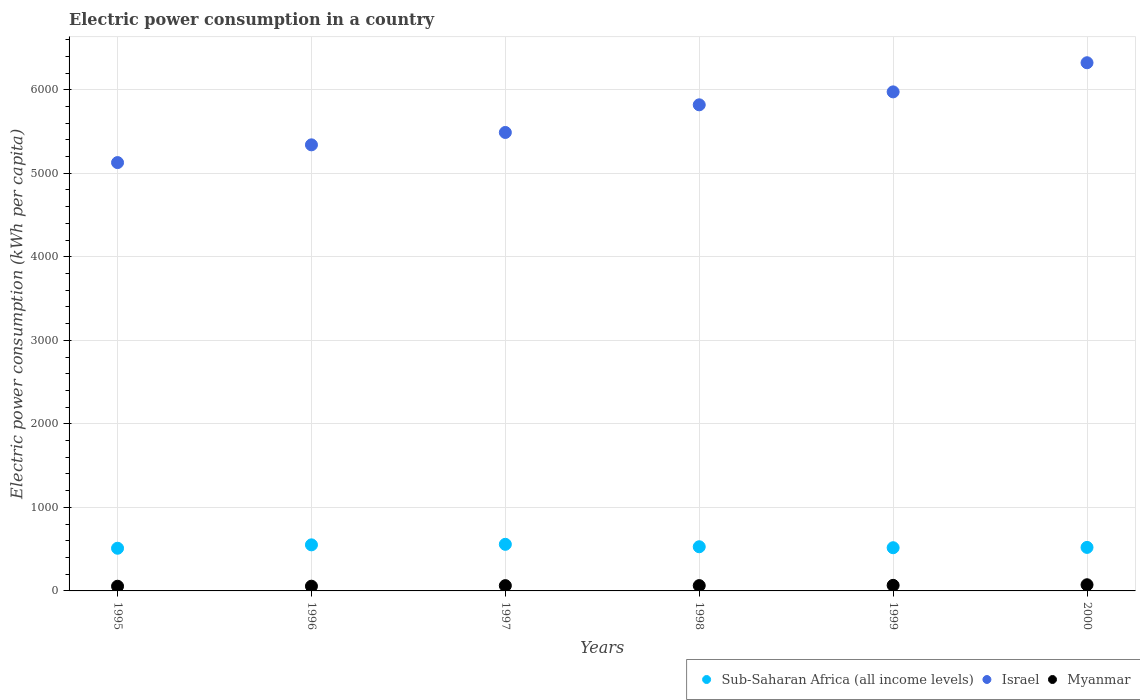Is the number of dotlines equal to the number of legend labels?
Make the answer very short. Yes. What is the electric power consumption in in Sub-Saharan Africa (all income levels) in 2000?
Your response must be concise. 520.97. Across all years, what is the maximum electric power consumption in in Myanmar?
Offer a very short reply. 73.76. Across all years, what is the minimum electric power consumption in in Israel?
Provide a succinct answer. 5127.86. In which year was the electric power consumption in in Myanmar maximum?
Keep it short and to the point. 2000. In which year was the electric power consumption in in Myanmar minimum?
Offer a terse response. 1995. What is the total electric power consumption in in Myanmar in the graph?
Provide a short and direct response. 380.1. What is the difference between the electric power consumption in in Myanmar in 1995 and that in 1996?
Your answer should be compact. -0.43. What is the difference between the electric power consumption in in Israel in 1995 and the electric power consumption in in Myanmar in 2000?
Provide a succinct answer. 5054.11. What is the average electric power consumption in in Israel per year?
Provide a succinct answer. 5678.94. In the year 1999, what is the difference between the electric power consumption in in Myanmar and electric power consumption in in Sub-Saharan Africa (all income levels)?
Your answer should be compact. -450.33. In how many years, is the electric power consumption in in Myanmar greater than 3400 kWh per capita?
Provide a succinct answer. 0. What is the ratio of the electric power consumption in in Israel in 1995 to that in 1997?
Ensure brevity in your answer.  0.93. Is the electric power consumption in in Myanmar in 1997 less than that in 1999?
Provide a succinct answer. Yes. What is the difference between the highest and the second highest electric power consumption in in Myanmar?
Offer a very short reply. 6.99. What is the difference between the highest and the lowest electric power consumption in in Israel?
Give a very brief answer. 1195.24. In how many years, is the electric power consumption in in Israel greater than the average electric power consumption in in Israel taken over all years?
Ensure brevity in your answer.  3. Is the sum of the electric power consumption in in Myanmar in 1996 and 1998 greater than the maximum electric power consumption in in Israel across all years?
Provide a succinct answer. No. Does the electric power consumption in in Sub-Saharan Africa (all income levels) monotonically increase over the years?
Your answer should be compact. No. Is the electric power consumption in in Myanmar strictly less than the electric power consumption in in Sub-Saharan Africa (all income levels) over the years?
Offer a terse response. Yes. How many years are there in the graph?
Your answer should be compact. 6. Are the values on the major ticks of Y-axis written in scientific E-notation?
Make the answer very short. No. Does the graph contain any zero values?
Give a very brief answer. No. Does the graph contain grids?
Ensure brevity in your answer.  Yes. Where does the legend appear in the graph?
Make the answer very short. Bottom right. How are the legend labels stacked?
Make the answer very short. Horizontal. What is the title of the graph?
Your answer should be very brief. Electric power consumption in a country. Does "Belgium" appear as one of the legend labels in the graph?
Give a very brief answer. No. What is the label or title of the Y-axis?
Provide a short and direct response. Electric power consumption (kWh per capita). What is the Electric power consumption (kWh per capita) of Sub-Saharan Africa (all income levels) in 1995?
Make the answer very short. 510.9. What is the Electric power consumption (kWh per capita) in Israel in 1995?
Make the answer very short. 5127.86. What is the Electric power consumption (kWh per capita) of Myanmar in 1995?
Keep it short and to the point. 56.14. What is the Electric power consumption (kWh per capita) of Sub-Saharan Africa (all income levels) in 1996?
Your answer should be compact. 551.54. What is the Electric power consumption (kWh per capita) of Israel in 1996?
Provide a succinct answer. 5340.3. What is the Electric power consumption (kWh per capita) of Myanmar in 1996?
Offer a terse response. 56.57. What is the Electric power consumption (kWh per capita) of Sub-Saharan Africa (all income levels) in 1997?
Ensure brevity in your answer.  557.91. What is the Electric power consumption (kWh per capita) of Israel in 1997?
Your answer should be compact. 5488.52. What is the Electric power consumption (kWh per capita) in Myanmar in 1997?
Make the answer very short. 63.25. What is the Electric power consumption (kWh per capita) in Sub-Saharan Africa (all income levels) in 1998?
Ensure brevity in your answer.  528.77. What is the Electric power consumption (kWh per capita) in Israel in 1998?
Your response must be concise. 5819.46. What is the Electric power consumption (kWh per capita) of Myanmar in 1998?
Ensure brevity in your answer.  63.62. What is the Electric power consumption (kWh per capita) in Sub-Saharan Africa (all income levels) in 1999?
Your response must be concise. 517.1. What is the Electric power consumption (kWh per capita) of Israel in 1999?
Keep it short and to the point. 5974.37. What is the Electric power consumption (kWh per capita) of Myanmar in 1999?
Keep it short and to the point. 66.76. What is the Electric power consumption (kWh per capita) of Sub-Saharan Africa (all income levels) in 2000?
Your answer should be very brief. 520.97. What is the Electric power consumption (kWh per capita) in Israel in 2000?
Keep it short and to the point. 6323.1. What is the Electric power consumption (kWh per capita) in Myanmar in 2000?
Your answer should be compact. 73.76. Across all years, what is the maximum Electric power consumption (kWh per capita) in Sub-Saharan Africa (all income levels)?
Give a very brief answer. 557.91. Across all years, what is the maximum Electric power consumption (kWh per capita) in Israel?
Give a very brief answer. 6323.1. Across all years, what is the maximum Electric power consumption (kWh per capita) in Myanmar?
Ensure brevity in your answer.  73.76. Across all years, what is the minimum Electric power consumption (kWh per capita) of Sub-Saharan Africa (all income levels)?
Your answer should be compact. 510.9. Across all years, what is the minimum Electric power consumption (kWh per capita) in Israel?
Offer a terse response. 5127.86. Across all years, what is the minimum Electric power consumption (kWh per capita) in Myanmar?
Offer a terse response. 56.14. What is the total Electric power consumption (kWh per capita) of Sub-Saharan Africa (all income levels) in the graph?
Ensure brevity in your answer.  3187.19. What is the total Electric power consumption (kWh per capita) of Israel in the graph?
Offer a terse response. 3.41e+04. What is the total Electric power consumption (kWh per capita) of Myanmar in the graph?
Offer a very short reply. 380.1. What is the difference between the Electric power consumption (kWh per capita) of Sub-Saharan Africa (all income levels) in 1995 and that in 1996?
Give a very brief answer. -40.64. What is the difference between the Electric power consumption (kWh per capita) in Israel in 1995 and that in 1996?
Your answer should be compact. -212.44. What is the difference between the Electric power consumption (kWh per capita) in Myanmar in 1995 and that in 1996?
Offer a very short reply. -0.43. What is the difference between the Electric power consumption (kWh per capita) of Sub-Saharan Africa (all income levels) in 1995 and that in 1997?
Give a very brief answer. -47.01. What is the difference between the Electric power consumption (kWh per capita) in Israel in 1995 and that in 1997?
Offer a terse response. -360.66. What is the difference between the Electric power consumption (kWh per capita) in Myanmar in 1995 and that in 1997?
Offer a terse response. -7.11. What is the difference between the Electric power consumption (kWh per capita) in Sub-Saharan Africa (all income levels) in 1995 and that in 1998?
Make the answer very short. -17.87. What is the difference between the Electric power consumption (kWh per capita) of Israel in 1995 and that in 1998?
Keep it short and to the point. -691.6. What is the difference between the Electric power consumption (kWh per capita) of Myanmar in 1995 and that in 1998?
Offer a very short reply. -7.48. What is the difference between the Electric power consumption (kWh per capita) in Sub-Saharan Africa (all income levels) in 1995 and that in 1999?
Provide a short and direct response. -6.19. What is the difference between the Electric power consumption (kWh per capita) of Israel in 1995 and that in 1999?
Your response must be concise. -846.5. What is the difference between the Electric power consumption (kWh per capita) of Myanmar in 1995 and that in 1999?
Your answer should be very brief. -10.62. What is the difference between the Electric power consumption (kWh per capita) of Sub-Saharan Africa (all income levels) in 1995 and that in 2000?
Make the answer very short. -10.07. What is the difference between the Electric power consumption (kWh per capita) in Israel in 1995 and that in 2000?
Provide a succinct answer. -1195.24. What is the difference between the Electric power consumption (kWh per capita) in Myanmar in 1995 and that in 2000?
Make the answer very short. -17.62. What is the difference between the Electric power consumption (kWh per capita) in Sub-Saharan Africa (all income levels) in 1996 and that in 1997?
Your answer should be very brief. -6.37. What is the difference between the Electric power consumption (kWh per capita) of Israel in 1996 and that in 1997?
Give a very brief answer. -148.22. What is the difference between the Electric power consumption (kWh per capita) in Myanmar in 1996 and that in 1997?
Make the answer very short. -6.68. What is the difference between the Electric power consumption (kWh per capita) in Sub-Saharan Africa (all income levels) in 1996 and that in 1998?
Offer a very short reply. 22.77. What is the difference between the Electric power consumption (kWh per capita) in Israel in 1996 and that in 1998?
Keep it short and to the point. -479.16. What is the difference between the Electric power consumption (kWh per capita) in Myanmar in 1996 and that in 1998?
Offer a very short reply. -7.05. What is the difference between the Electric power consumption (kWh per capita) in Sub-Saharan Africa (all income levels) in 1996 and that in 1999?
Offer a terse response. 34.45. What is the difference between the Electric power consumption (kWh per capita) in Israel in 1996 and that in 1999?
Give a very brief answer. -634.07. What is the difference between the Electric power consumption (kWh per capita) in Myanmar in 1996 and that in 1999?
Your answer should be compact. -10.2. What is the difference between the Electric power consumption (kWh per capita) in Sub-Saharan Africa (all income levels) in 1996 and that in 2000?
Offer a very short reply. 30.57. What is the difference between the Electric power consumption (kWh per capita) in Israel in 1996 and that in 2000?
Make the answer very short. -982.8. What is the difference between the Electric power consumption (kWh per capita) of Myanmar in 1996 and that in 2000?
Your response must be concise. -17.19. What is the difference between the Electric power consumption (kWh per capita) in Sub-Saharan Africa (all income levels) in 1997 and that in 1998?
Make the answer very short. 29.15. What is the difference between the Electric power consumption (kWh per capita) in Israel in 1997 and that in 1998?
Your answer should be very brief. -330.94. What is the difference between the Electric power consumption (kWh per capita) in Myanmar in 1997 and that in 1998?
Make the answer very short. -0.37. What is the difference between the Electric power consumption (kWh per capita) of Sub-Saharan Africa (all income levels) in 1997 and that in 1999?
Keep it short and to the point. 40.82. What is the difference between the Electric power consumption (kWh per capita) of Israel in 1997 and that in 1999?
Keep it short and to the point. -485.85. What is the difference between the Electric power consumption (kWh per capita) of Myanmar in 1997 and that in 1999?
Provide a succinct answer. -3.51. What is the difference between the Electric power consumption (kWh per capita) in Sub-Saharan Africa (all income levels) in 1997 and that in 2000?
Make the answer very short. 36.94. What is the difference between the Electric power consumption (kWh per capita) of Israel in 1997 and that in 2000?
Your answer should be very brief. -834.58. What is the difference between the Electric power consumption (kWh per capita) in Myanmar in 1997 and that in 2000?
Keep it short and to the point. -10.51. What is the difference between the Electric power consumption (kWh per capita) of Sub-Saharan Africa (all income levels) in 1998 and that in 1999?
Make the answer very short. 11.67. What is the difference between the Electric power consumption (kWh per capita) of Israel in 1998 and that in 1999?
Your response must be concise. -154.91. What is the difference between the Electric power consumption (kWh per capita) in Myanmar in 1998 and that in 1999?
Keep it short and to the point. -3.14. What is the difference between the Electric power consumption (kWh per capita) of Sub-Saharan Africa (all income levels) in 1998 and that in 2000?
Ensure brevity in your answer.  7.8. What is the difference between the Electric power consumption (kWh per capita) of Israel in 1998 and that in 2000?
Keep it short and to the point. -503.64. What is the difference between the Electric power consumption (kWh per capita) of Myanmar in 1998 and that in 2000?
Your answer should be compact. -10.14. What is the difference between the Electric power consumption (kWh per capita) in Sub-Saharan Africa (all income levels) in 1999 and that in 2000?
Your answer should be very brief. -3.87. What is the difference between the Electric power consumption (kWh per capita) of Israel in 1999 and that in 2000?
Make the answer very short. -348.74. What is the difference between the Electric power consumption (kWh per capita) in Myanmar in 1999 and that in 2000?
Offer a terse response. -6.99. What is the difference between the Electric power consumption (kWh per capita) of Sub-Saharan Africa (all income levels) in 1995 and the Electric power consumption (kWh per capita) of Israel in 1996?
Provide a succinct answer. -4829.4. What is the difference between the Electric power consumption (kWh per capita) in Sub-Saharan Africa (all income levels) in 1995 and the Electric power consumption (kWh per capita) in Myanmar in 1996?
Provide a succinct answer. 454.33. What is the difference between the Electric power consumption (kWh per capita) of Israel in 1995 and the Electric power consumption (kWh per capita) of Myanmar in 1996?
Keep it short and to the point. 5071.3. What is the difference between the Electric power consumption (kWh per capita) of Sub-Saharan Africa (all income levels) in 1995 and the Electric power consumption (kWh per capita) of Israel in 1997?
Offer a terse response. -4977.62. What is the difference between the Electric power consumption (kWh per capita) in Sub-Saharan Africa (all income levels) in 1995 and the Electric power consumption (kWh per capita) in Myanmar in 1997?
Offer a terse response. 447.65. What is the difference between the Electric power consumption (kWh per capita) in Israel in 1995 and the Electric power consumption (kWh per capita) in Myanmar in 1997?
Provide a short and direct response. 5064.61. What is the difference between the Electric power consumption (kWh per capita) of Sub-Saharan Africa (all income levels) in 1995 and the Electric power consumption (kWh per capita) of Israel in 1998?
Your response must be concise. -5308.56. What is the difference between the Electric power consumption (kWh per capita) of Sub-Saharan Africa (all income levels) in 1995 and the Electric power consumption (kWh per capita) of Myanmar in 1998?
Provide a succinct answer. 447.28. What is the difference between the Electric power consumption (kWh per capita) of Israel in 1995 and the Electric power consumption (kWh per capita) of Myanmar in 1998?
Provide a short and direct response. 5064.24. What is the difference between the Electric power consumption (kWh per capita) of Sub-Saharan Africa (all income levels) in 1995 and the Electric power consumption (kWh per capita) of Israel in 1999?
Provide a short and direct response. -5463.47. What is the difference between the Electric power consumption (kWh per capita) in Sub-Saharan Africa (all income levels) in 1995 and the Electric power consumption (kWh per capita) in Myanmar in 1999?
Provide a short and direct response. 444.14. What is the difference between the Electric power consumption (kWh per capita) in Israel in 1995 and the Electric power consumption (kWh per capita) in Myanmar in 1999?
Keep it short and to the point. 5061.1. What is the difference between the Electric power consumption (kWh per capita) of Sub-Saharan Africa (all income levels) in 1995 and the Electric power consumption (kWh per capita) of Israel in 2000?
Keep it short and to the point. -5812.2. What is the difference between the Electric power consumption (kWh per capita) in Sub-Saharan Africa (all income levels) in 1995 and the Electric power consumption (kWh per capita) in Myanmar in 2000?
Provide a short and direct response. 437.14. What is the difference between the Electric power consumption (kWh per capita) of Israel in 1995 and the Electric power consumption (kWh per capita) of Myanmar in 2000?
Keep it short and to the point. 5054.11. What is the difference between the Electric power consumption (kWh per capita) of Sub-Saharan Africa (all income levels) in 1996 and the Electric power consumption (kWh per capita) of Israel in 1997?
Your answer should be compact. -4936.98. What is the difference between the Electric power consumption (kWh per capita) in Sub-Saharan Africa (all income levels) in 1996 and the Electric power consumption (kWh per capita) in Myanmar in 1997?
Your answer should be compact. 488.29. What is the difference between the Electric power consumption (kWh per capita) of Israel in 1996 and the Electric power consumption (kWh per capita) of Myanmar in 1997?
Offer a terse response. 5277.05. What is the difference between the Electric power consumption (kWh per capita) in Sub-Saharan Africa (all income levels) in 1996 and the Electric power consumption (kWh per capita) in Israel in 1998?
Your answer should be compact. -5267.92. What is the difference between the Electric power consumption (kWh per capita) of Sub-Saharan Africa (all income levels) in 1996 and the Electric power consumption (kWh per capita) of Myanmar in 1998?
Ensure brevity in your answer.  487.92. What is the difference between the Electric power consumption (kWh per capita) of Israel in 1996 and the Electric power consumption (kWh per capita) of Myanmar in 1998?
Give a very brief answer. 5276.68. What is the difference between the Electric power consumption (kWh per capita) in Sub-Saharan Africa (all income levels) in 1996 and the Electric power consumption (kWh per capita) in Israel in 1999?
Give a very brief answer. -5422.83. What is the difference between the Electric power consumption (kWh per capita) in Sub-Saharan Africa (all income levels) in 1996 and the Electric power consumption (kWh per capita) in Myanmar in 1999?
Offer a very short reply. 484.78. What is the difference between the Electric power consumption (kWh per capita) in Israel in 1996 and the Electric power consumption (kWh per capita) in Myanmar in 1999?
Provide a succinct answer. 5273.54. What is the difference between the Electric power consumption (kWh per capita) of Sub-Saharan Africa (all income levels) in 1996 and the Electric power consumption (kWh per capita) of Israel in 2000?
Your answer should be very brief. -5771.56. What is the difference between the Electric power consumption (kWh per capita) of Sub-Saharan Africa (all income levels) in 1996 and the Electric power consumption (kWh per capita) of Myanmar in 2000?
Provide a succinct answer. 477.78. What is the difference between the Electric power consumption (kWh per capita) of Israel in 1996 and the Electric power consumption (kWh per capita) of Myanmar in 2000?
Offer a very short reply. 5266.54. What is the difference between the Electric power consumption (kWh per capita) in Sub-Saharan Africa (all income levels) in 1997 and the Electric power consumption (kWh per capita) in Israel in 1998?
Your answer should be compact. -5261.55. What is the difference between the Electric power consumption (kWh per capita) of Sub-Saharan Africa (all income levels) in 1997 and the Electric power consumption (kWh per capita) of Myanmar in 1998?
Ensure brevity in your answer.  494.29. What is the difference between the Electric power consumption (kWh per capita) in Israel in 1997 and the Electric power consumption (kWh per capita) in Myanmar in 1998?
Offer a terse response. 5424.9. What is the difference between the Electric power consumption (kWh per capita) in Sub-Saharan Africa (all income levels) in 1997 and the Electric power consumption (kWh per capita) in Israel in 1999?
Offer a very short reply. -5416.45. What is the difference between the Electric power consumption (kWh per capita) of Sub-Saharan Africa (all income levels) in 1997 and the Electric power consumption (kWh per capita) of Myanmar in 1999?
Your answer should be compact. 491.15. What is the difference between the Electric power consumption (kWh per capita) of Israel in 1997 and the Electric power consumption (kWh per capita) of Myanmar in 1999?
Ensure brevity in your answer.  5421.76. What is the difference between the Electric power consumption (kWh per capita) in Sub-Saharan Africa (all income levels) in 1997 and the Electric power consumption (kWh per capita) in Israel in 2000?
Keep it short and to the point. -5765.19. What is the difference between the Electric power consumption (kWh per capita) of Sub-Saharan Africa (all income levels) in 1997 and the Electric power consumption (kWh per capita) of Myanmar in 2000?
Your answer should be compact. 484.16. What is the difference between the Electric power consumption (kWh per capita) in Israel in 1997 and the Electric power consumption (kWh per capita) in Myanmar in 2000?
Keep it short and to the point. 5414.76. What is the difference between the Electric power consumption (kWh per capita) in Sub-Saharan Africa (all income levels) in 1998 and the Electric power consumption (kWh per capita) in Israel in 1999?
Ensure brevity in your answer.  -5445.6. What is the difference between the Electric power consumption (kWh per capita) of Sub-Saharan Africa (all income levels) in 1998 and the Electric power consumption (kWh per capita) of Myanmar in 1999?
Offer a terse response. 462.01. What is the difference between the Electric power consumption (kWh per capita) in Israel in 1998 and the Electric power consumption (kWh per capita) in Myanmar in 1999?
Offer a terse response. 5752.7. What is the difference between the Electric power consumption (kWh per capita) in Sub-Saharan Africa (all income levels) in 1998 and the Electric power consumption (kWh per capita) in Israel in 2000?
Your response must be concise. -5794.34. What is the difference between the Electric power consumption (kWh per capita) of Sub-Saharan Africa (all income levels) in 1998 and the Electric power consumption (kWh per capita) of Myanmar in 2000?
Provide a short and direct response. 455.01. What is the difference between the Electric power consumption (kWh per capita) of Israel in 1998 and the Electric power consumption (kWh per capita) of Myanmar in 2000?
Offer a very short reply. 5745.7. What is the difference between the Electric power consumption (kWh per capita) in Sub-Saharan Africa (all income levels) in 1999 and the Electric power consumption (kWh per capita) in Israel in 2000?
Give a very brief answer. -5806.01. What is the difference between the Electric power consumption (kWh per capita) of Sub-Saharan Africa (all income levels) in 1999 and the Electric power consumption (kWh per capita) of Myanmar in 2000?
Keep it short and to the point. 443.34. What is the difference between the Electric power consumption (kWh per capita) of Israel in 1999 and the Electric power consumption (kWh per capita) of Myanmar in 2000?
Offer a very short reply. 5900.61. What is the average Electric power consumption (kWh per capita) of Sub-Saharan Africa (all income levels) per year?
Offer a terse response. 531.2. What is the average Electric power consumption (kWh per capita) in Israel per year?
Your response must be concise. 5678.94. What is the average Electric power consumption (kWh per capita) of Myanmar per year?
Your response must be concise. 63.35. In the year 1995, what is the difference between the Electric power consumption (kWh per capita) of Sub-Saharan Africa (all income levels) and Electric power consumption (kWh per capita) of Israel?
Make the answer very short. -4616.96. In the year 1995, what is the difference between the Electric power consumption (kWh per capita) of Sub-Saharan Africa (all income levels) and Electric power consumption (kWh per capita) of Myanmar?
Your answer should be compact. 454.76. In the year 1995, what is the difference between the Electric power consumption (kWh per capita) in Israel and Electric power consumption (kWh per capita) in Myanmar?
Give a very brief answer. 5071.72. In the year 1996, what is the difference between the Electric power consumption (kWh per capita) in Sub-Saharan Africa (all income levels) and Electric power consumption (kWh per capita) in Israel?
Give a very brief answer. -4788.76. In the year 1996, what is the difference between the Electric power consumption (kWh per capita) in Sub-Saharan Africa (all income levels) and Electric power consumption (kWh per capita) in Myanmar?
Provide a short and direct response. 494.97. In the year 1996, what is the difference between the Electric power consumption (kWh per capita) in Israel and Electric power consumption (kWh per capita) in Myanmar?
Provide a succinct answer. 5283.73. In the year 1997, what is the difference between the Electric power consumption (kWh per capita) in Sub-Saharan Africa (all income levels) and Electric power consumption (kWh per capita) in Israel?
Provide a short and direct response. -4930.61. In the year 1997, what is the difference between the Electric power consumption (kWh per capita) of Sub-Saharan Africa (all income levels) and Electric power consumption (kWh per capita) of Myanmar?
Your answer should be very brief. 494.66. In the year 1997, what is the difference between the Electric power consumption (kWh per capita) in Israel and Electric power consumption (kWh per capita) in Myanmar?
Provide a short and direct response. 5425.27. In the year 1998, what is the difference between the Electric power consumption (kWh per capita) in Sub-Saharan Africa (all income levels) and Electric power consumption (kWh per capita) in Israel?
Your answer should be compact. -5290.69. In the year 1998, what is the difference between the Electric power consumption (kWh per capita) in Sub-Saharan Africa (all income levels) and Electric power consumption (kWh per capita) in Myanmar?
Keep it short and to the point. 465.15. In the year 1998, what is the difference between the Electric power consumption (kWh per capita) in Israel and Electric power consumption (kWh per capita) in Myanmar?
Offer a very short reply. 5755.84. In the year 1999, what is the difference between the Electric power consumption (kWh per capita) in Sub-Saharan Africa (all income levels) and Electric power consumption (kWh per capita) in Israel?
Keep it short and to the point. -5457.27. In the year 1999, what is the difference between the Electric power consumption (kWh per capita) in Sub-Saharan Africa (all income levels) and Electric power consumption (kWh per capita) in Myanmar?
Ensure brevity in your answer.  450.33. In the year 1999, what is the difference between the Electric power consumption (kWh per capita) in Israel and Electric power consumption (kWh per capita) in Myanmar?
Ensure brevity in your answer.  5907.6. In the year 2000, what is the difference between the Electric power consumption (kWh per capita) of Sub-Saharan Africa (all income levels) and Electric power consumption (kWh per capita) of Israel?
Make the answer very short. -5802.13. In the year 2000, what is the difference between the Electric power consumption (kWh per capita) in Sub-Saharan Africa (all income levels) and Electric power consumption (kWh per capita) in Myanmar?
Your response must be concise. 447.21. In the year 2000, what is the difference between the Electric power consumption (kWh per capita) of Israel and Electric power consumption (kWh per capita) of Myanmar?
Keep it short and to the point. 6249.35. What is the ratio of the Electric power consumption (kWh per capita) of Sub-Saharan Africa (all income levels) in 1995 to that in 1996?
Ensure brevity in your answer.  0.93. What is the ratio of the Electric power consumption (kWh per capita) in Israel in 1995 to that in 1996?
Keep it short and to the point. 0.96. What is the ratio of the Electric power consumption (kWh per capita) of Myanmar in 1995 to that in 1996?
Your answer should be compact. 0.99. What is the ratio of the Electric power consumption (kWh per capita) in Sub-Saharan Africa (all income levels) in 1995 to that in 1997?
Your answer should be very brief. 0.92. What is the ratio of the Electric power consumption (kWh per capita) of Israel in 1995 to that in 1997?
Keep it short and to the point. 0.93. What is the ratio of the Electric power consumption (kWh per capita) in Myanmar in 1995 to that in 1997?
Provide a succinct answer. 0.89. What is the ratio of the Electric power consumption (kWh per capita) in Sub-Saharan Africa (all income levels) in 1995 to that in 1998?
Offer a terse response. 0.97. What is the ratio of the Electric power consumption (kWh per capita) of Israel in 1995 to that in 1998?
Your response must be concise. 0.88. What is the ratio of the Electric power consumption (kWh per capita) in Myanmar in 1995 to that in 1998?
Your answer should be compact. 0.88. What is the ratio of the Electric power consumption (kWh per capita) of Sub-Saharan Africa (all income levels) in 1995 to that in 1999?
Ensure brevity in your answer.  0.99. What is the ratio of the Electric power consumption (kWh per capita) in Israel in 1995 to that in 1999?
Your answer should be very brief. 0.86. What is the ratio of the Electric power consumption (kWh per capita) of Myanmar in 1995 to that in 1999?
Your answer should be compact. 0.84. What is the ratio of the Electric power consumption (kWh per capita) of Sub-Saharan Africa (all income levels) in 1995 to that in 2000?
Offer a terse response. 0.98. What is the ratio of the Electric power consumption (kWh per capita) in Israel in 1995 to that in 2000?
Make the answer very short. 0.81. What is the ratio of the Electric power consumption (kWh per capita) in Myanmar in 1995 to that in 2000?
Give a very brief answer. 0.76. What is the ratio of the Electric power consumption (kWh per capita) in Sub-Saharan Africa (all income levels) in 1996 to that in 1997?
Make the answer very short. 0.99. What is the ratio of the Electric power consumption (kWh per capita) of Myanmar in 1996 to that in 1997?
Provide a short and direct response. 0.89. What is the ratio of the Electric power consumption (kWh per capita) of Sub-Saharan Africa (all income levels) in 1996 to that in 1998?
Ensure brevity in your answer.  1.04. What is the ratio of the Electric power consumption (kWh per capita) in Israel in 1996 to that in 1998?
Your answer should be compact. 0.92. What is the ratio of the Electric power consumption (kWh per capita) of Myanmar in 1996 to that in 1998?
Ensure brevity in your answer.  0.89. What is the ratio of the Electric power consumption (kWh per capita) of Sub-Saharan Africa (all income levels) in 1996 to that in 1999?
Make the answer very short. 1.07. What is the ratio of the Electric power consumption (kWh per capita) of Israel in 1996 to that in 1999?
Make the answer very short. 0.89. What is the ratio of the Electric power consumption (kWh per capita) in Myanmar in 1996 to that in 1999?
Make the answer very short. 0.85. What is the ratio of the Electric power consumption (kWh per capita) of Sub-Saharan Africa (all income levels) in 1996 to that in 2000?
Make the answer very short. 1.06. What is the ratio of the Electric power consumption (kWh per capita) of Israel in 1996 to that in 2000?
Offer a terse response. 0.84. What is the ratio of the Electric power consumption (kWh per capita) in Myanmar in 1996 to that in 2000?
Offer a very short reply. 0.77. What is the ratio of the Electric power consumption (kWh per capita) of Sub-Saharan Africa (all income levels) in 1997 to that in 1998?
Provide a short and direct response. 1.06. What is the ratio of the Electric power consumption (kWh per capita) in Israel in 1997 to that in 1998?
Give a very brief answer. 0.94. What is the ratio of the Electric power consumption (kWh per capita) in Sub-Saharan Africa (all income levels) in 1997 to that in 1999?
Make the answer very short. 1.08. What is the ratio of the Electric power consumption (kWh per capita) in Israel in 1997 to that in 1999?
Your answer should be compact. 0.92. What is the ratio of the Electric power consumption (kWh per capita) in Myanmar in 1997 to that in 1999?
Make the answer very short. 0.95. What is the ratio of the Electric power consumption (kWh per capita) in Sub-Saharan Africa (all income levels) in 1997 to that in 2000?
Offer a terse response. 1.07. What is the ratio of the Electric power consumption (kWh per capita) in Israel in 1997 to that in 2000?
Your answer should be very brief. 0.87. What is the ratio of the Electric power consumption (kWh per capita) of Myanmar in 1997 to that in 2000?
Keep it short and to the point. 0.86. What is the ratio of the Electric power consumption (kWh per capita) of Sub-Saharan Africa (all income levels) in 1998 to that in 1999?
Your response must be concise. 1.02. What is the ratio of the Electric power consumption (kWh per capita) of Israel in 1998 to that in 1999?
Your response must be concise. 0.97. What is the ratio of the Electric power consumption (kWh per capita) in Myanmar in 1998 to that in 1999?
Give a very brief answer. 0.95. What is the ratio of the Electric power consumption (kWh per capita) in Israel in 1998 to that in 2000?
Keep it short and to the point. 0.92. What is the ratio of the Electric power consumption (kWh per capita) of Myanmar in 1998 to that in 2000?
Your response must be concise. 0.86. What is the ratio of the Electric power consumption (kWh per capita) in Israel in 1999 to that in 2000?
Make the answer very short. 0.94. What is the ratio of the Electric power consumption (kWh per capita) in Myanmar in 1999 to that in 2000?
Make the answer very short. 0.91. What is the difference between the highest and the second highest Electric power consumption (kWh per capita) of Sub-Saharan Africa (all income levels)?
Provide a short and direct response. 6.37. What is the difference between the highest and the second highest Electric power consumption (kWh per capita) of Israel?
Provide a succinct answer. 348.74. What is the difference between the highest and the second highest Electric power consumption (kWh per capita) in Myanmar?
Provide a short and direct response. 6.99. What is the difference between the highest and the lowest Electric power consumption (kWh per capita) of Sub-Saharan Africa (all income levels)?
Offer a terse response. 47.01. What is the difference between the highest and the lowest Electric power consumption (kWh per capita) of Israel?
Your answer should be compact. 1195.24. What is the difference between the highest and the lowest Electric power consumption (kWh per capita) of Myanmar?
Make the answer very short. 17.62. 